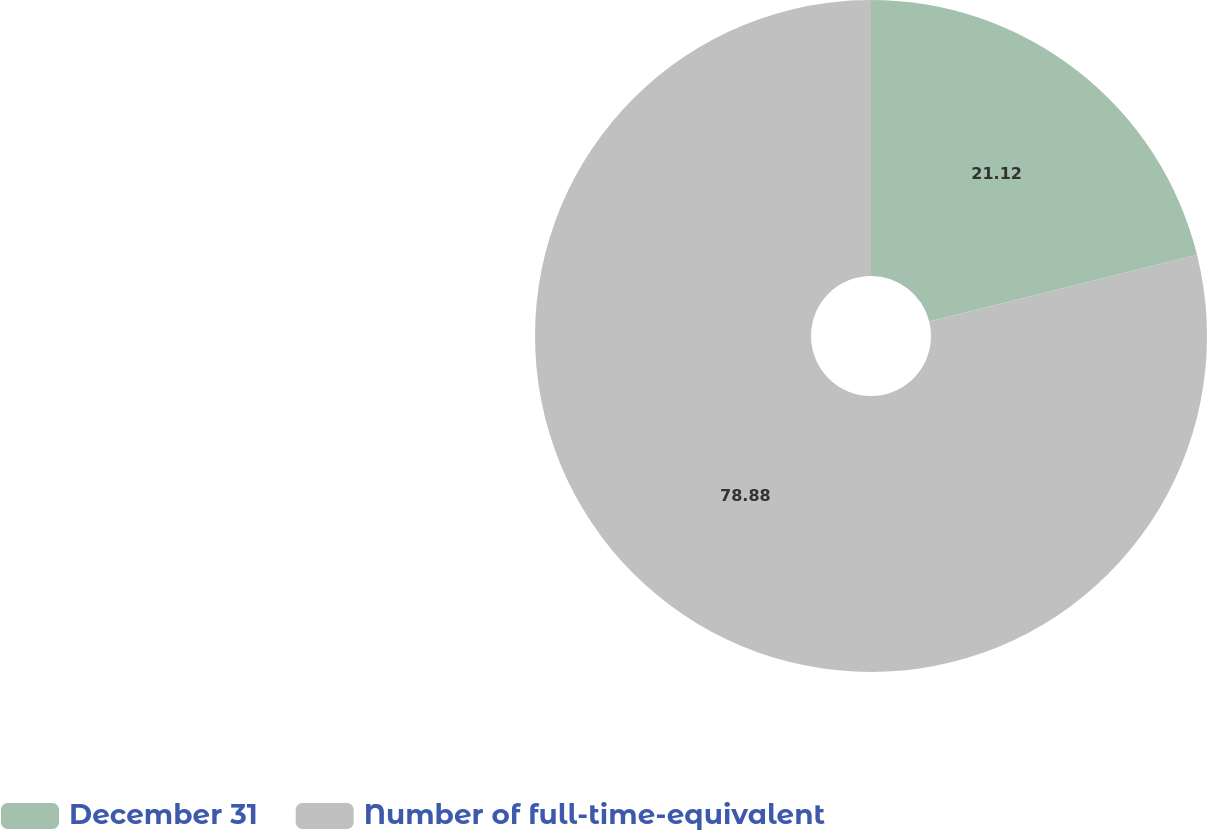<chart> <loc_0><loc_0><loc_500><loc_500><pie_chart><fcel>December 31<fcel>Number of full-time-equivalent<nl><fcel>21.12%<fcel>78.88%<nl></chart> 